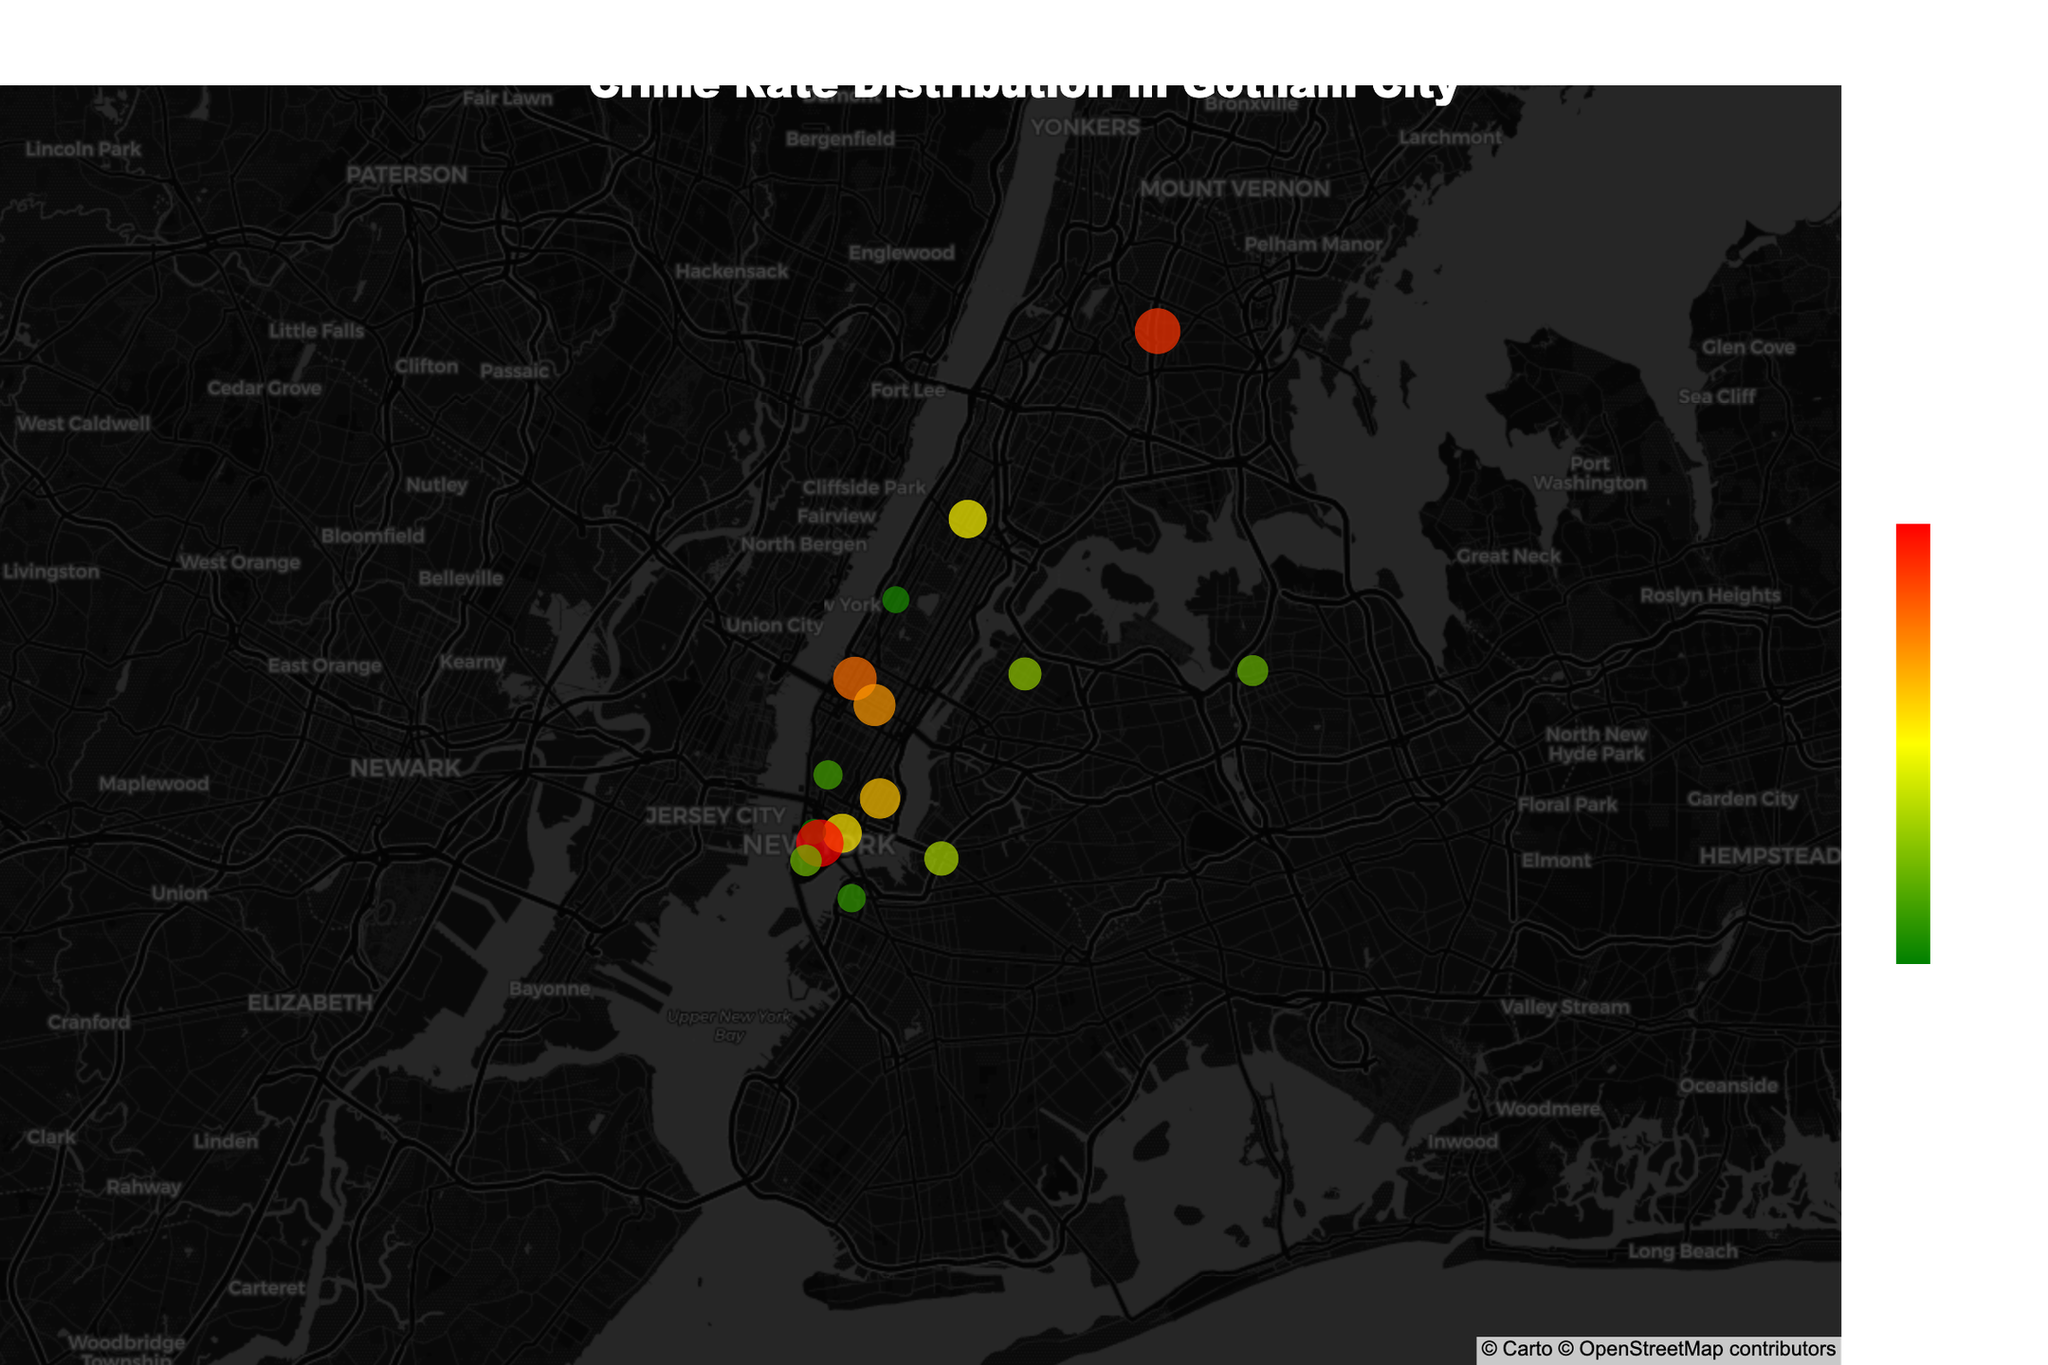What's the title of the figure? The title is located at the top-center of the figure; it reads, "Crime Rate Distribution in Gotham City".
Answer: Crime Rate Distribution in Gotham City Which neighborhood is classified as a Hotspot with the highest crime rate? The color scale indicates high crime rates as red. The neighborhood classified as a Hotspot and with the highest crime rate is Downtown.
Answer: Downtown How many neighborhoods are classified as Safe Zones? Safe Zones have a low crime rate and are indicated by green. The neighborhoods classified as Safe Zones are Upper West Side, Brooklyn Heights, Greenwich Village, and Tribeca, totaling four.
Answer: 4 Compare the crime rate of East Village and Harlem. Which has a higher crime rate? By identifying the colors and the labels of East Village and Harlem, East Village (62) has a higher crime rate than Harlem (56).
Answer: East Village What is the combined crime rate of hell's Kitchen and Midtown? The crime rate of Hell's Kitchen is 72, and Midtown is 67. Adding them together gives 72 + 67 = 139.
Answer: 139 Is Flushing considered a high-risk area based on the figure? The hover data and colors show that Flushing is not in the High Risk category; it's classified under Low Risk with a crime rate of 37.
Answer: No Which neighborhoods fall under the Moderate Risk category? The hover data indicates that Harlem, Williamsburg, and Chinatown are classified as Moderate Risk.
Answer: Harlem, Williamsburg, Chinatown What is the average crime rate of all Safe Zones? The crime rates for Safe Zones are Upper West Side (28), Brooklyn Heights (31), Greenwich Village (33), and Tribeca (25). Average = (28 + 31 + 33 + 25) / 4 = 117 / 4 = 29.25.
Answer: 29.25 Between Bronx Park and Financial District, which one is depicted as a Hotspot? Bronx Park has a color and label indicating it’s a Hotspot, while Financial District is labeled Low Risk.
Answer: Bronx Park Which neighborhood has a crime rate closest to 50? Checking the figure, Williamsburg has a crime rate of 45, closest to 50 among the listed crime rates.
Answer: Williamsburg 